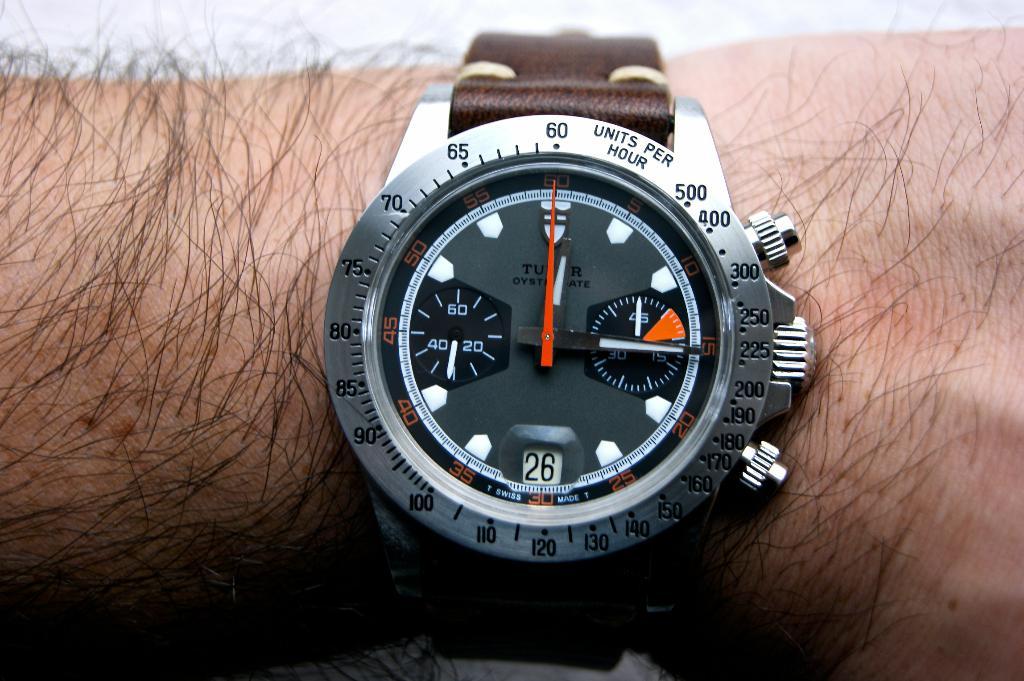This a hand watch?
Give a very brief answer. Yes. 